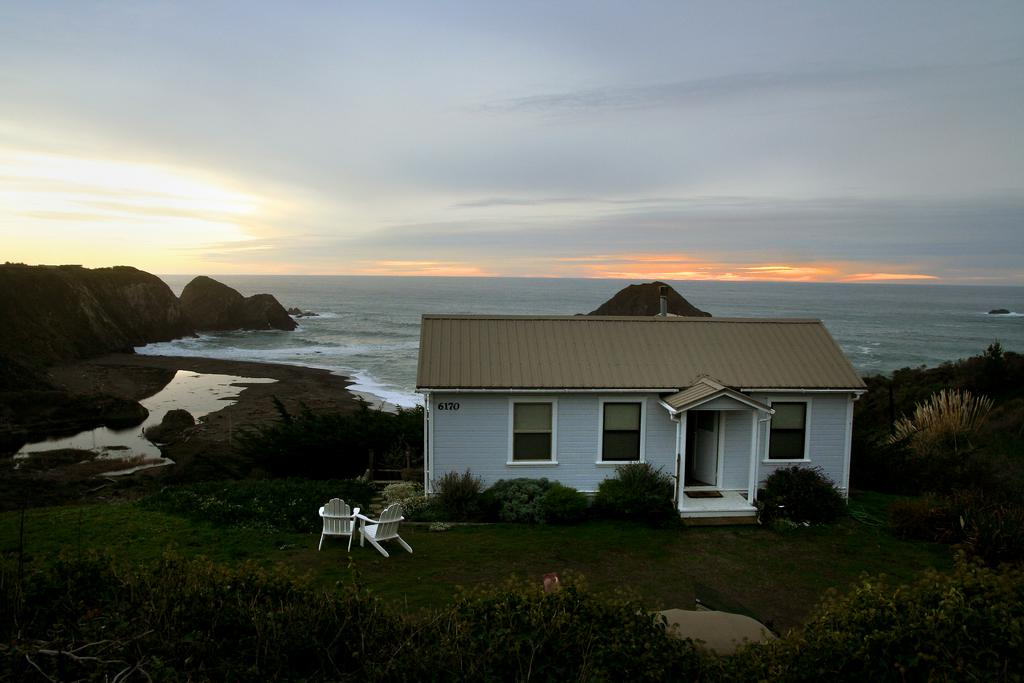What type of structure is in the image? There is a house in the image. What type of furniture is in the image? There are chairs in the image. What natural feature is visible in the image? There is water visible in the image. What type of landscape can be seen in the image? There are hills in the image. What is visible in the sky in the image? The sky is visible in the image, and clouds are present. What type of badge is being used to copy the wrench in the image? There is no badge, wrench, or copying activity present in the image. 